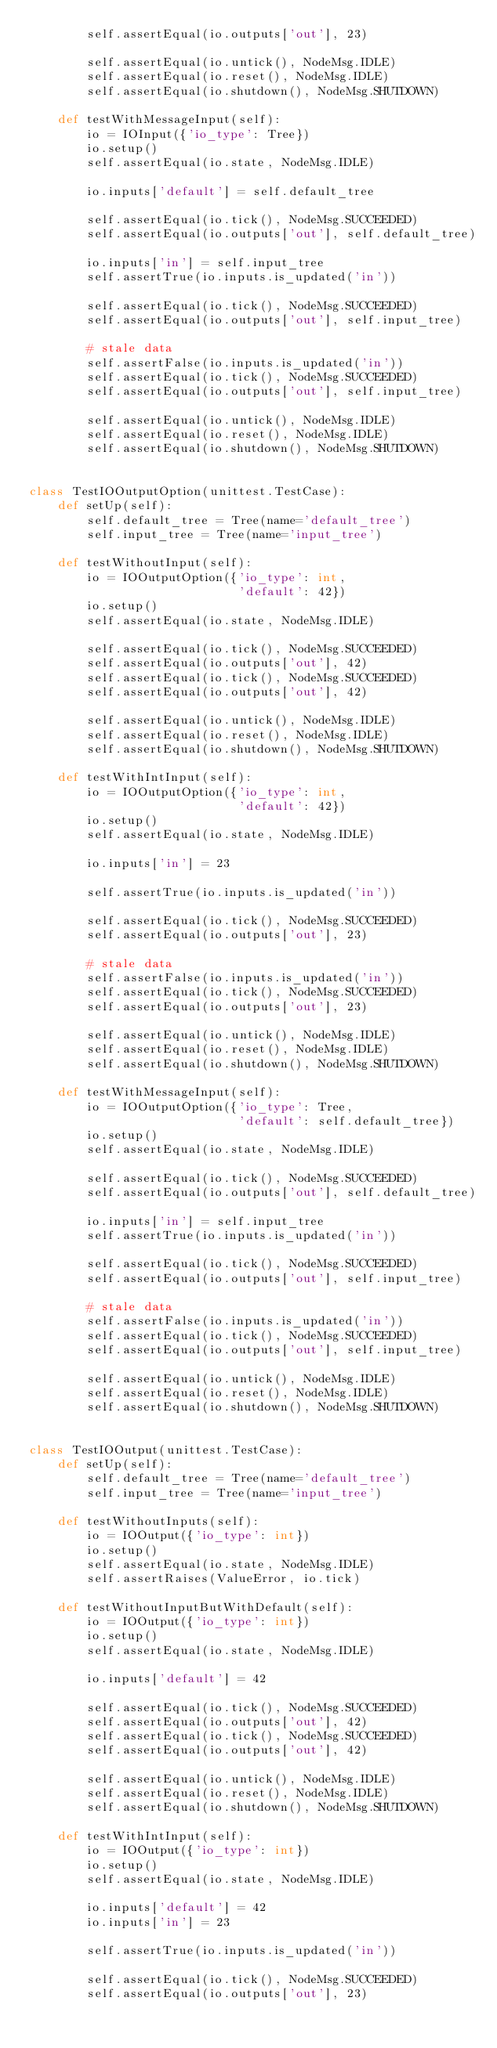Convert code to text. <code><loc_0><loc_0><loc_500><loc_500><_Python_>        self.assertEqual(io.outputs['out'], 23)

        self.assertEqual(io.untick(), NodeMsg.IDLE)
        self.assertEqual(io.reset(), NodeMsg.IDLE)
        self.assertEqual(io.shutdown(), NodeMsg.SHUTDOWN)

    def testWithMessageInput(self):
        io = IOInput({'io_type': Tree})
        io.setup()
        self.assertEqual(io.state, NodeMsg.IDLE)

        io.inputs['default'] = self.default_tree

        self.assertEqual(io.tick(), NodeMsg.SUCCEEDED)
        self.assertEqual(io.outputs['out'], self.default_tree)

        io.inputs['in'] = self.input_tree
        self.assertTrue(io.inputs.is_updated('in'))

        self.assertEqual(io.tick(), NodeMsg.SUCCEEDED)
        self.assertEqual(io.outputs['out'], self.input_tree)

        # stale data
        self.assertFalse(io.inputs.is_updated('in'))
        self.assertEqual(io.tick(), NodeMsg.SUCCEEDED)
        self.assertEqual(io.outputs['out'], self.input_tree)

        self.assertEqual(io.untick(), NodeMsg.IDLE)
        self.assertEqual(io.reset(), NodeMsg.IDLE)
        self.assertEqual(io.shutdown(), NodeMsg.SHUTDOWN)


class TestIOOutputOption(unittest.TestCase):
    def setUp(self):
        self.default_tree = Tree(name='default_tree')
        self.input_tree = Tree(name='input_tree')

    def testWithoutInput(self):
        io = IOOutputOption({'io_type': int,
                             'default': 42})
        io.setup()
        self.assertEqual(io.state, NodeMsg.IDLE)

        self.assertEqual(io.tick(), NodeMsg.SUCCEEDED)
        self.assertEqual(io.outputs['out'], 42)
        self.assertEqual(io.tick(), NodeMsg.SUCCEEDED)
        self.assertEqual(io.outputs['out'], 42)

        self.assertEqual(io.untick(), NodeMsg.IDLE)
        self.assertEqual(io.reset(), NodeMsg.IDLE)
        self.assertEqual(io.shutdown(), NodeMsg.SHUTDOWN)

    def testWithIntInput(self):
        io = IOOutputOption({'io_type': int,
                             'default': 42})
        io.setup()
        self.assertEqual(io.state, NodeMsg.IDLE)

        io.inputs['in'] = 23

        self.assertTrue(io.inputs.is_updated('in'))

        self.assertEqual(io.tick(), NodeMsg.SUCCEEDED)
        self.assertEqual(io.outputs['out'], 23)

        # stale data
        self.assertFalse(io.inputs.is_updated('in'))
        self.assertEqual(io.tick(), NodeMsg.SUCCEEDED)
        self.assertEqual(io.outputs['out'], 23)

        self.assertEqual(io.untick(), NodeMsg.IDLE)
        self.assertEqual(io.reset(), NodeMsg.IDLE)
        self.assertEqual(io.shutdown(), NodeMsg.SHUTDOWN)

    def testWithMessageInput(self):
        io = IOOutputOption({'io_type': Tree,
                             'default': self.default_tree})
        io.setup()
        self.assertEqual(io.state, NodeMsg.IDLE)

        self.assertEqual(io.tick(), NodeMsg.SUCCEEDED)
        self.assertEqual(io.outputs['out'], self.default_tree)

        io.inputs['in'] = self.input_tree
        self.assertTrue(io.inputs.is_updated('in'))

        self.assertEqual(io.tick(), NodeMsg.SUCCEEDED)
        self.assertEqual(io.outputs['out'], self.input_tree)

        # stale data
        self.assertFalse(io.inputs.is_updated('in'))
        self.assertEqual(io.tick(), NodeMsg.SUCCEEDED)
        self.assertEqual(io.outputs['out'], self.input_tree)

        self.assertEqual(io.untick(), NodeMsg.IDLE)
        self.assertEqual(io.reset(), NodeMsg.IDLE)
        self.assertEqual(io.shutdown(), NodeMsg.SHUTDOWN)


class TestIOOutput(unittest.TestCase):
    def setUp(self):
        self.default_tree = Tree(name='default_tree')
        self.input_tree = Tree(name='input_tree')

    def testWithoutInputs(self):
        io = IOOutput({'io_type': int})
        io.setup()
        self.assertEqual(io.state, NodeMsg.IDLE)
        self.assertRaises(ValueError, io.tick)

    def testWithoutInputButWithDefault(self):
        io = IOOutput({'io_type': int})
        io.setup()
        self.assertEqual(io.state, NodeMsg.IDLE)

        io.inputs['default'] = 42

        self.assertEqual(io.tick(), NodeMsg.SUCCEEDED)
        self.assertEqual(io.outputs['out'], 42)
        self.assertEqual(io.tick(), NodeMsg.SUCCEEDED)
        self.assertEqual(io.outputs['out'], 42)

        self.assertEqual(io.untick(), NodeMsg.IDLE)
        self.assertEqual(io.reset(), NodeMsg.IDLE)
        self.assertEqual(io.shutdown(), NodeMsg.SHUTDOWN)

    def testWithIntInput(self):
        io = IOOutput({'io_type': int})
        io.setup()
        self.assertEqual(io.state, NodeMsg.IDLE)

        io.inputs['default'] = 42
        io.inputs['in'] = 23

        self.assertTrue(io.inputs.is_updated('in'))

        self.assertEqual(io.tick(), NodeMsg.SUCCEEDED)
        self.assertEqual(io.outputs['out'], 23)
</code> 